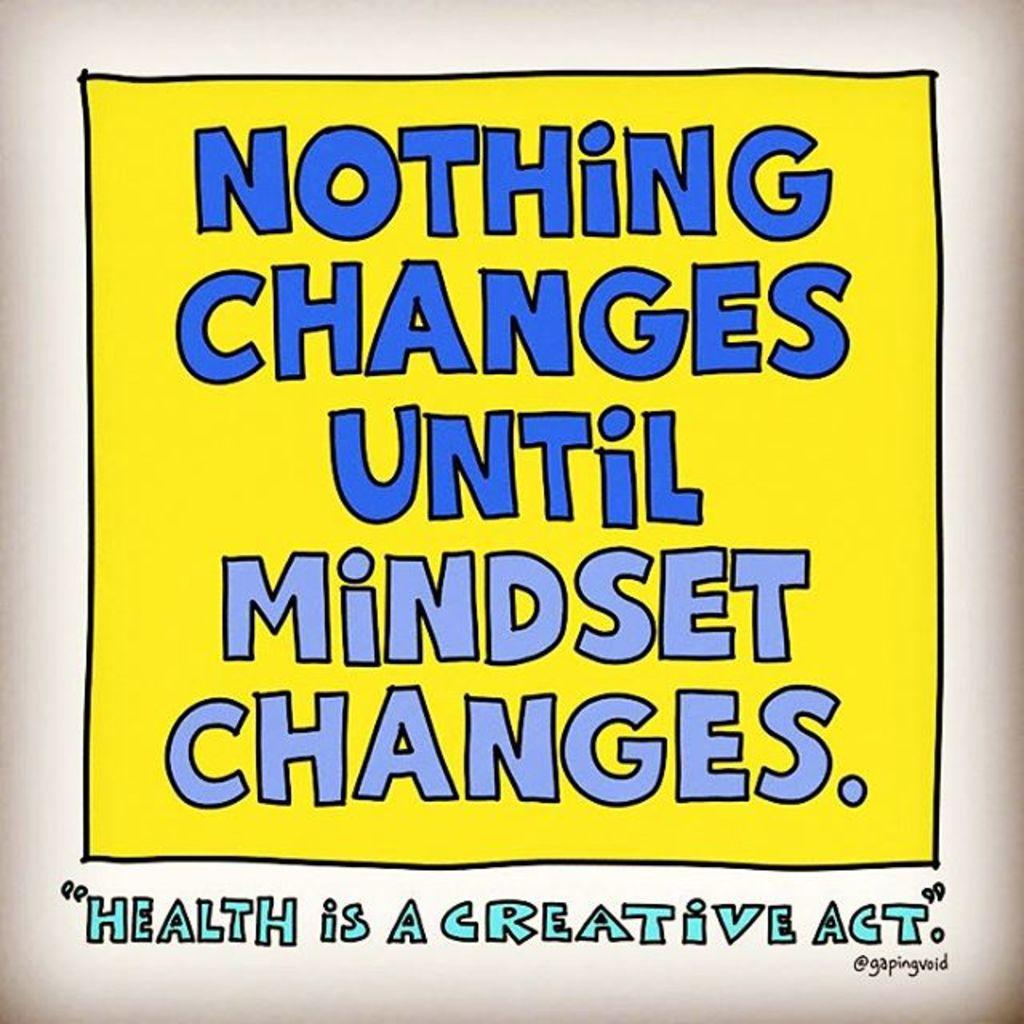<image>
Summarize the visual content of the image. The poster promotes healthy mental habits for success. 